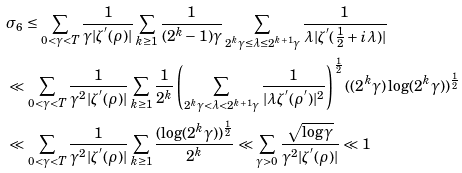<formula> <loc_0><loc_0><loc_500><loc_500>& \sigma _ { 6 } \leq \sum _ { 0 < \gamma < T } \frac { 1 } { \gamma | \zeta ^ { ^ { \prime } } ( \rho ) | } \sum _ { k \geq 1 } \frac { 1 } { ( 2 ^ { k } - 1 ) \gamma } \sum _ { 2 ^ { k } \gamma \leq \lambda \leq 2 ^ { k + 1 } \gamma } \frac { 1 } { \lambda | \zeta ^ { ^ { \prime } } ( \frac { 1 } { 2 } + i \lambda ) | } \\ & \ll \sum _ { 0 < \gamma < T } \frac { 1 } { \gamma ^ { 2 } | \zeta ^ { ^ { \prime } } ( \rho ) | } \sum _ { k \geq 1 } \frac { 1 } { 2 ^ { k } } \left ( \sum _ { 2 ^ { k } \gamma < \lambda < 2 ^ { k + 1 } \gamma } \frac { 1 } { | \lambda \zeta ^ { ^ { \prime } } ( \rho ^ { ^ { \prime } } ) | ^ { 2 } } \right ) ^ { \frac { 1 } { 2 } } ( ( 2 ^ { k } \gamma ) \log ( 2 ^ { k } \gamma ) ) ^ { \frac { 1 } { 2 } } \\ & \ll \sum _ { 0 < \gamma < T } \frac { 1 } { \gamma ^ { 2 } | \zeta ^ { ^ { \prime } } ( \rho ) | } \sum _ { k \geq 1 } \frac { ( \log ( 2 ^ { k } \gamma ) ) ^ { \frac { 1 } { 2 } } } { 2 ^ { k } } \ll \sum _ { \gamma > 0 } \frac { \sqrt { \log \gamma } } { \gamma ^ { 2 } | \zeta ^ { ^ { \prime } } ( \rho ) | } \ll 1 \\</formula> 